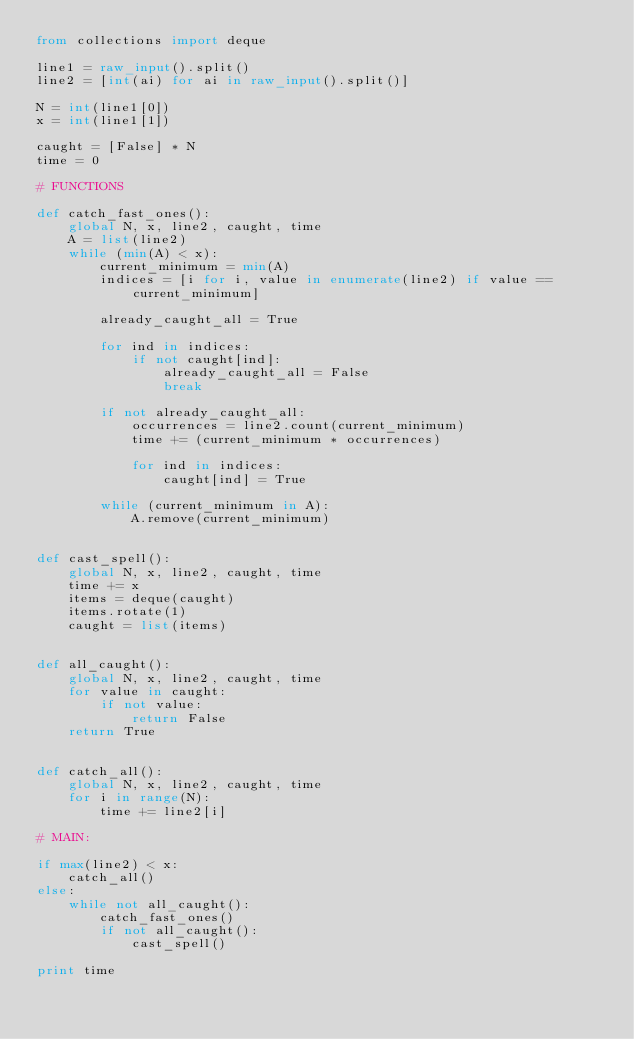<code> <loc_0><loc_0><loc_500><loc_500><_Python_>from collections import deque

line1 = raw_input().split()
line2 = [int(ai) for ai in raw_input().split()]

N = int(line1[0])
x = int(line1[1])

caught = [False] * N
time = 0

# FUNCTIONS

def catch_fast_ones():
    global N, x, line2, caught, time
    A = list(line2)
    while (min(A) < x):
        current_minimum = min(A)
        indices = [i for i, value in enumerate(line2) if value == current_minimum]

        already_caught_all = True

        for ind in indices:
            if not caught[ind]:
                already_caught_all = False
                break

        if not already_caught_all:
            occurrences = line2.count(current_minimum)
            time += (current_minimum * occurrences)

            for ind in indices:
                caught[ind] = True

        while (current_minimum in A):
            A.remove(current_minimum)


def cast_spell():
    global N, x, line2, caught, time
    time += x
    items = deque(caught)
    items.rotate(1)
    caught = list(items)


def all_caught():
    global N, x, line2, caught, time
    for value in caught:
        if not value:
            return False
    return True


def catch_all():
    global N, x, line2, caught, time
    for i in range(N):
        time += line2[i]

# MAIN:

if max(line2) < x:
    catch_all()
else:
    while not all_caught():
        catch_fast_ones()
        if not all_caught():
            cast_spell()

print time
</code> 